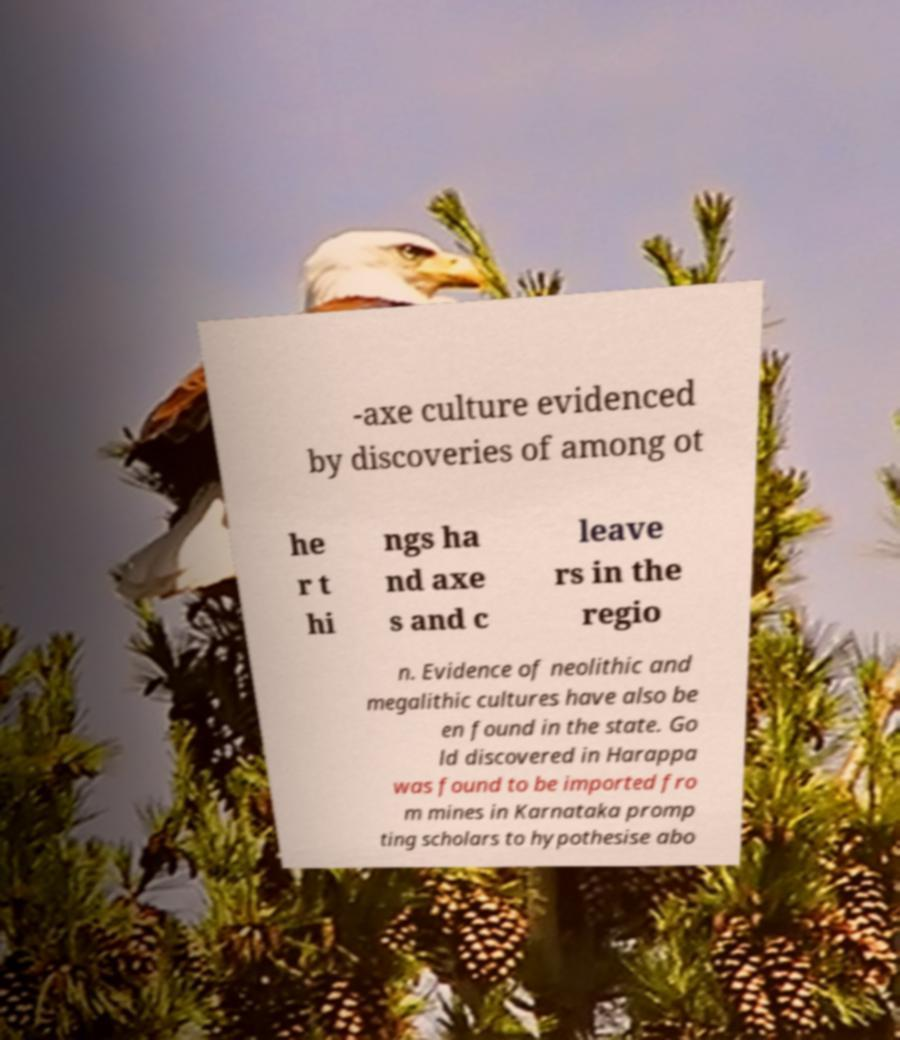What messages or text are displayed in this image? I need them in a readable, typed format. -axe culture evidenced by discoveries of among ot he r t hi ngs ha nd axe s and c leave rs in the regio n. Evidence of neolithic and megalithic cultures have also be en found in the state. Go ld discovered in Harappa was found to be imported fro m mines in Karnataka promp ting scholars to hypothesise abo 